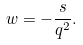<formula> <loc_0><loc_0><loc_500><loc_500>w = - \frac { s } { q ^ { 2 } } .</formula> 